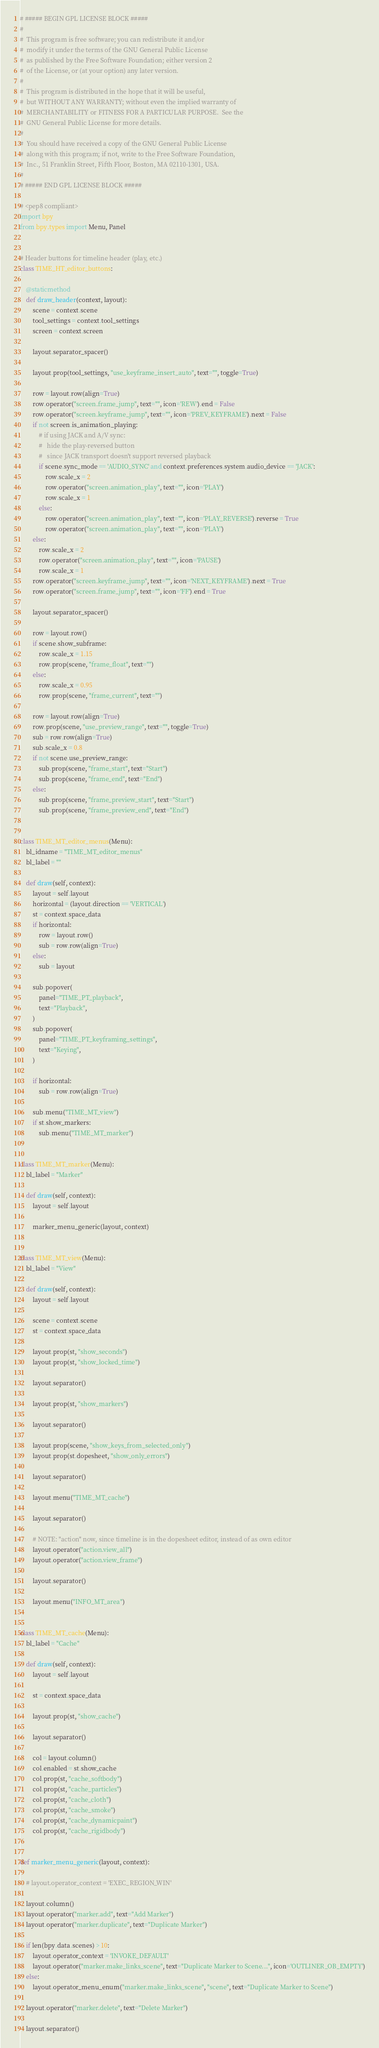<code> <loc_0><loc_0><loc_500><loc_500><_Python_># ##### BEGIN GPL LICENSE BLOCK #####
#
#  This program is free software; you can redistribute it and/or
#  modify it under the terms of the GNU General Public License
#  as published by the Free Software Foundation; either version 2
#  of the License, or (at your option) any later version.
#
#  This program is distributed in the hope that it will be useful,
#  but WITHOUT ANY WARRANTY; without even the implied warranty of
#  MERCHANTABILITY or FITNESS FOR A PARTICULAR PURPOSE.  See the
#  GNU General Public License for more details.
#
#  You should have received a copy of the GNU General Public License
#  along with this program; if not, write to the Free Software Foundation,
#  Inc., 51 Franklin Street, Fifth Floor, Boston, MA 02110-1301, USA.
#
# ##### END GPL LICENSE BLOCK #####

# <pep8 compliant>
import bpy
from bpy.types import Menu, Panel


# Header buttons for timeline header (play, etc.)
class TIME_HT_editor_buttons:

    @staticmethod
    def draw_header(context, layout):
        scene = context.scene
        tool_settings = context.tool_settings
        screen = context.screen

        layout.separator_spacer()

        layout.prop(tool_settings, "use_keyframe_insert_auto", text="", toggle=True)

        row = layout.row(align=True)
        row.operator("screen.frame_jump", text="", icon='REW').end = False
        row.operator("screen.keyframe_jump", text="", icon='PREV_KEYFRAME').next = False
        if not screen.is_animation_playing:
            # if using JACK and A/V sync:
            #   hide the play-reversed button
            #   since JACK transport doesn't support reversed playback
            if scene.sync_mode == 'AUDIO_SYNC' and context.preferences.system.audio_device == 'JACK':
                row.scale_x = 2
                row.operator("screen.animation_play", text="", icon='PLAY')
                row.scale_x = 1
            else:
                row.operator("screen.animation_play", text="", icon='PLAY_REVERSE').reverse = True
                row.operator("screen.animation_play", text="", icon='PLAY')
        else:
            row.scale_x = 2
            row.operator("screen.animation_play", text="", icon='PAUSE')
            row.scale_x = 1
        row.operator("screen.keyframe_jump", text="", icon='NEXT_KEYFRAME').next = True
        row.operator("screen.frame_jump", text="", icon='FF').end = True

        layout.separator_spacer()

        row = layout.row()
        if scene.show_subframe:
            row.scale_x = 1.15
            row.prop(scene, "frame_float", text="")
        else:
            row.scale_x = 0.95
            row.prop(scene, "frame_current", text="")

        row = layout.row(align=True)
        row.prop(scene, "use_preview_range", text="", toggle=True)
        sub = row.row(align=True)
        sub.scale_x = 0.8
        if not scene.use_preview_range:
            sub.prop(scene, "frame_start", text="Start")
            sub.prop(scene, "frame_end", text="End")
        else:
            sub.prop(scene, "frame_preview_start", text="Start")
            sub.prop(scene, "frame_preview_end", text="End")


class TIME_MT_editor_menus(Menu):
    bl_idname = "TIME_MT_editor_menus"
    bl_label = ""

    def draw(self, context):
        layout = self.layout
        horizontal = (layout.direction == 'VERTICAL')
        st = context.space_data
        if horizontal:
            row = layout.row()
            sub = row.row(align=True)
        else:
            sub = layout

        sub.popover(
            panel="TIME_PT_playback",
            text="Playback",
        )
        sub.popover(
            panel="TIME_PT_keyframing_settings",
            text="Keying",
        )

        if horizontal:
            sub = row.row(align=True)

        sub.menu("TIME_MT_view")
        if st.show_markers:
            sub.menu("TIME_MT_marker")


class TIME_MT_marker(Menu):
    bl_label = "Marker"

    def draw(self, context):
        layout = self.layout

        marker_menu_generic(layout, context)


class TIME_MT_view(Menu):
    bl_label = "View"

    def draw(self, context):
        layout = self.layout

        scene = context.scene
        st = context.space_data

        layout.prop(st, "show_seconds")
        layout.prop(st, "show_locked_time")

        layout.separator()

        layout.prop(st, "show_markers")

        layout.separator()

        layout.prop(scene, "show_keys_from_selected_only")
        layout.prop(st.dopesheet, "show_only_errors")

        layout.separator()

        layout.menu("TIME_MT_cache")

        layout.separator()

        # NOTE: "action" now, since timeline is in the dopesheet editor, instead of as own editor
        layout.operator("action.view_all")
        layout.operator("action.view_frame")

        layout.separator()

        layout.menu("INFO_MT_area")


class TIME_MT_cache(Menu):
    bl_label = "Cache"

    def draw(self, context):
        layout = self.layout

        st = context.space_data

        layout.prop(st, "show_cache")

        layout.separator()

        col = layout.column()
        col.enabled = st.show_cache
        col.prop(st, "cache_softbody")
        col.prop(st, "cache_particles")
        col.prop(st, "cache_cloth")
        col.prop(st, "cache_smoke")
        col.prop(st, "cache_dynamicpaint")
        col.prop(st, "cache_rigidbody")


def marker_menu_generic(layout, context):

    # layout.operator_context = 'EXEC_REGION_WIN'

    layout.column()
    layout.operator("marker.add", text="Add Marker")
    layout.operator("marker.duplicate", text="Duplicate Marker")

    if len(bpy.data.scenes) > 10:
        layout.operator_context = 'INVOKE_DEFAULT'
        layout.operator("marker.make_links_scene", text="Duplicate Marker to Scene...", icon='OUTLINER_OB_EMPTY')
    else:
        layout.operator_menu_enum("marker.make_links_scene", "scene", text="Duplicate Marker to Scene")

    layout.operator("marker.delete", text="Delete Marker")

    layout.separator()
</code> 